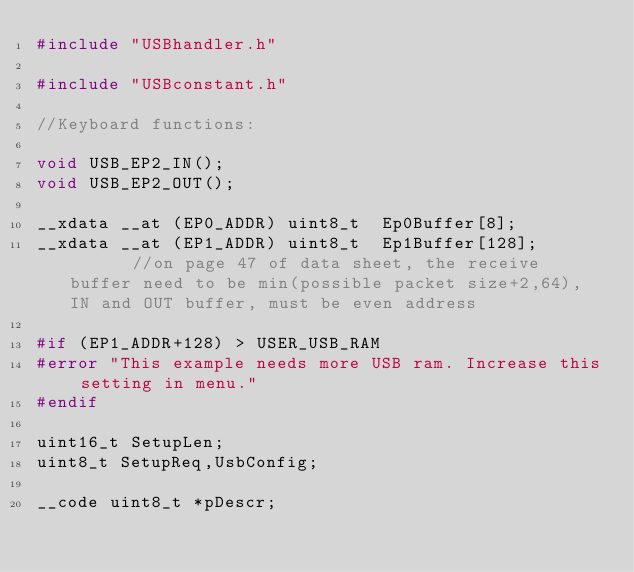<code> <loc_0><loc_0><loc_500><loc_500><_C_>#include "USBhandler.h"

#include "USBconstant.h"

//Keyboard functions:

void USB_EP2_IN();
void USB_EP2_OUT();

__xdata __at (EP0_ADDR) uint8_t  Ep0Buffer[8];     
__xdata __at (EP1_ADDR) uint8_t  Ep1Buffer[128];       //on page 47 of data sheet, the receive buffer need to be min(possible packet size+2,64), IN and OUT buffer, must be even address

#if (EP1_ADDR+128) > USER_USB_RAM
#error "This example needs more USB ram. Increase this setting in menu."
#endif

uint16_t SetupLen;
uint8_t SetupReq,UsbConfig;

__code uint8_t *pDescr;
</code> 